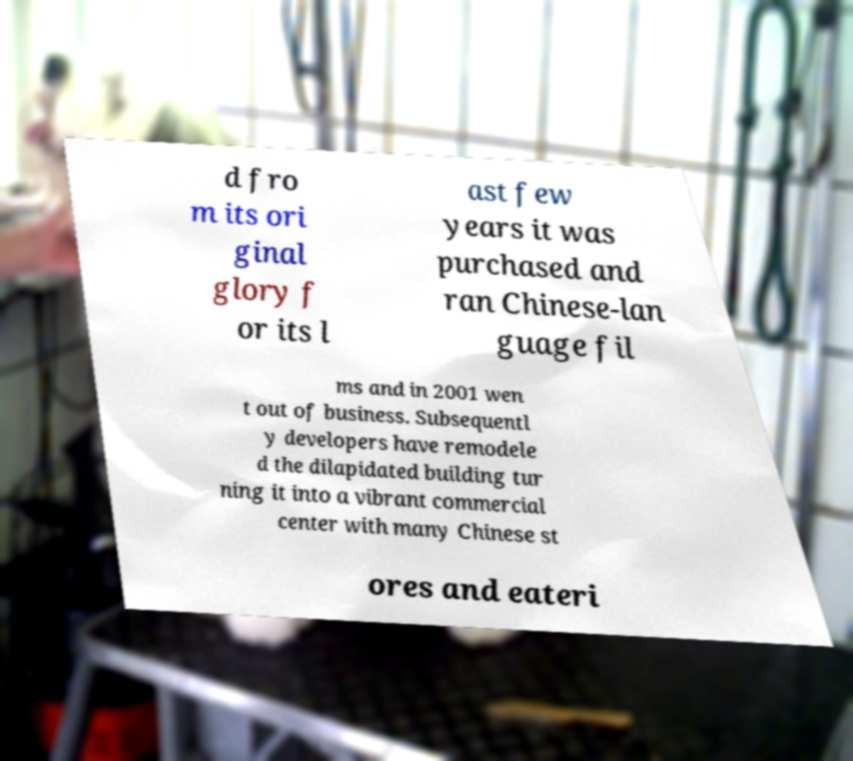There's text embedded in this image that I need extracted. Can you transcribe it verbatim? d fro m its ori ginal glory f or its l ast few years it was purchased and ran Chinese-lan guage fil ms and in 2001 wen t out of business. Subsequentl y developers have remodele d the dilapidated building tur ning it into a vibrant commercial center with many Chinese st ores and eateri 